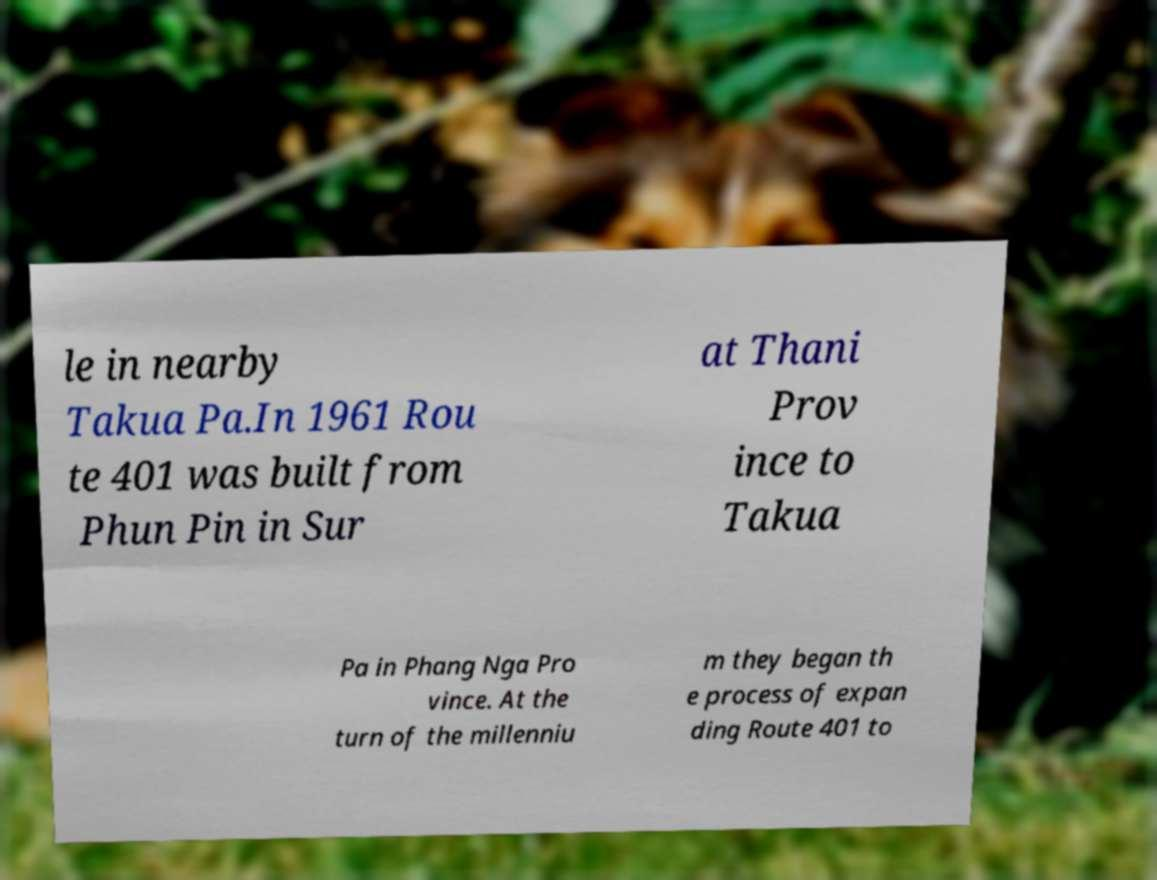For documentation purposes, I need the text within this image transcribed. Could you provide that? le in nearby Takua Pa.In 1961 Rou te 401 was built from Phun Pin in Sur at Thani Prov ince to Takua Pa in Phang Nga Pro vince. At the turn of the millenniu m they began th e process of expan ding Route 401 to 